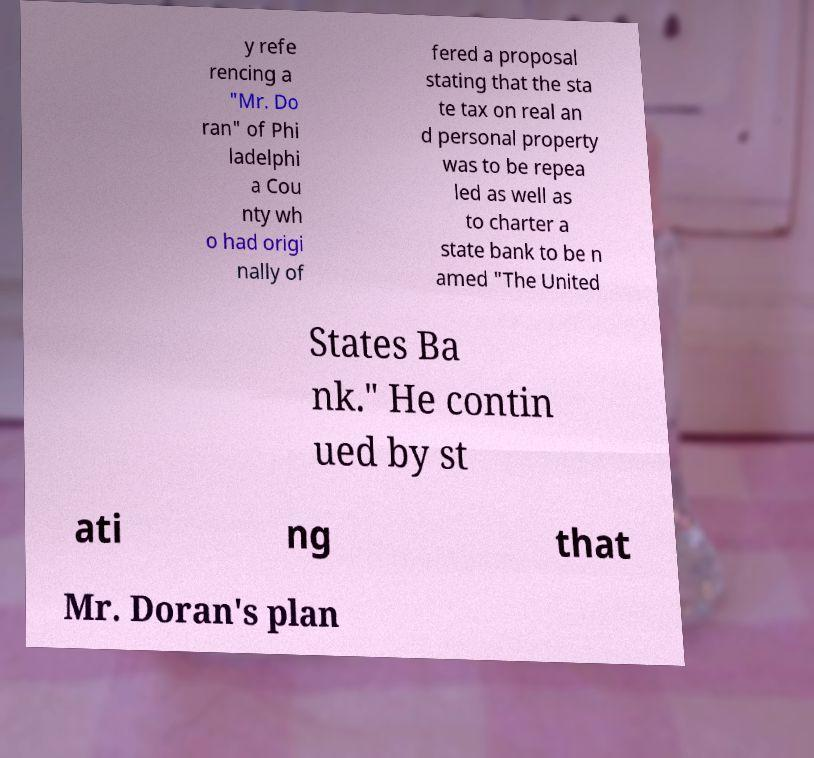I need the written content from this picture converted into text. Can you do that? y refe rencing a "Mr. Do ran" of Phi ladelphi a Cou nty wh o had origi nally of fered a proposal stating that the sta te tax on real an d personal property was to be repea led as well as to charter a state bank to be n amed "The United States Ba nk." He contin ued by st ati ng that Mr. Doran's plan 